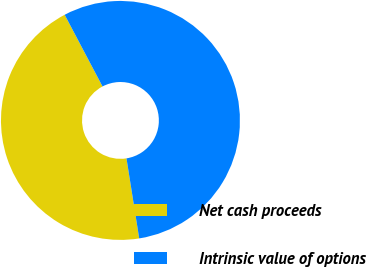Convert chart to OTSL. <chart><loc_0><loc_0><loc_500><loc_500><pie_chart><fcel>Net cash proceeds<fcel>Intrinsic value of options<nl><fcel>44.78%<fcel>55.22%<nl></chart> 